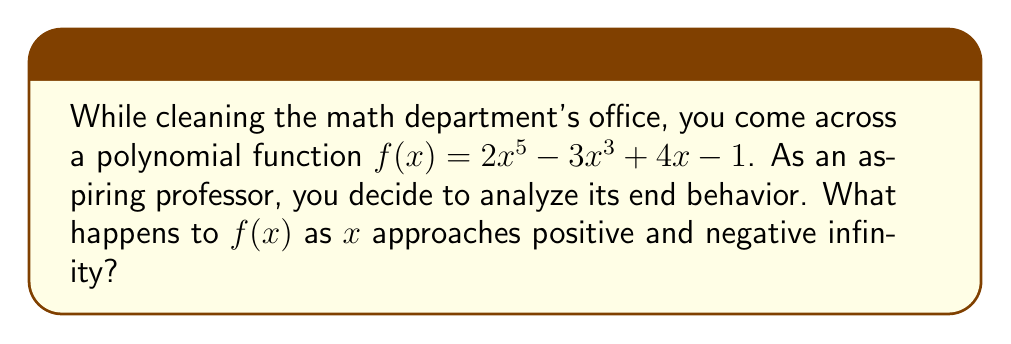Provide a solution to this math problem. Let's analyze this step-by-step:

1) The end behavior of a polynomial is determined by its leading term (the term with the highest degree) as $x$ approaches infinity.

2) In this case, the polynomial is $f(x) = 2x^5 - 3x^3 + 4x - 1$

3) The leading term is $2x^5$

4) The degree of the polynomial is 5 (odd)

5) The coefficient of the leading term is 2 (positive)

6) For odd-degree polynomials with a positive leading coefficient:
   - As $x \to +\infty$, $f(x) \to +\infty$
   - As $x \to -\infty$, $f(x) \to -\infty$

7) This is because for very large positive or negative $x$ values, the $x^5$ term will dominate all lower-degree terms.

8) The positive coefficient (2) ensures that the function follows the natural behavior of $x^5$, which goes to positive infinity for large positive $x$ and negative infinity for large negative $x$.
Answer: As $x \to +\infty$, $f(x) \to +\infty$; as $x \to -\infty$, $f(x) \to -\infty$ 